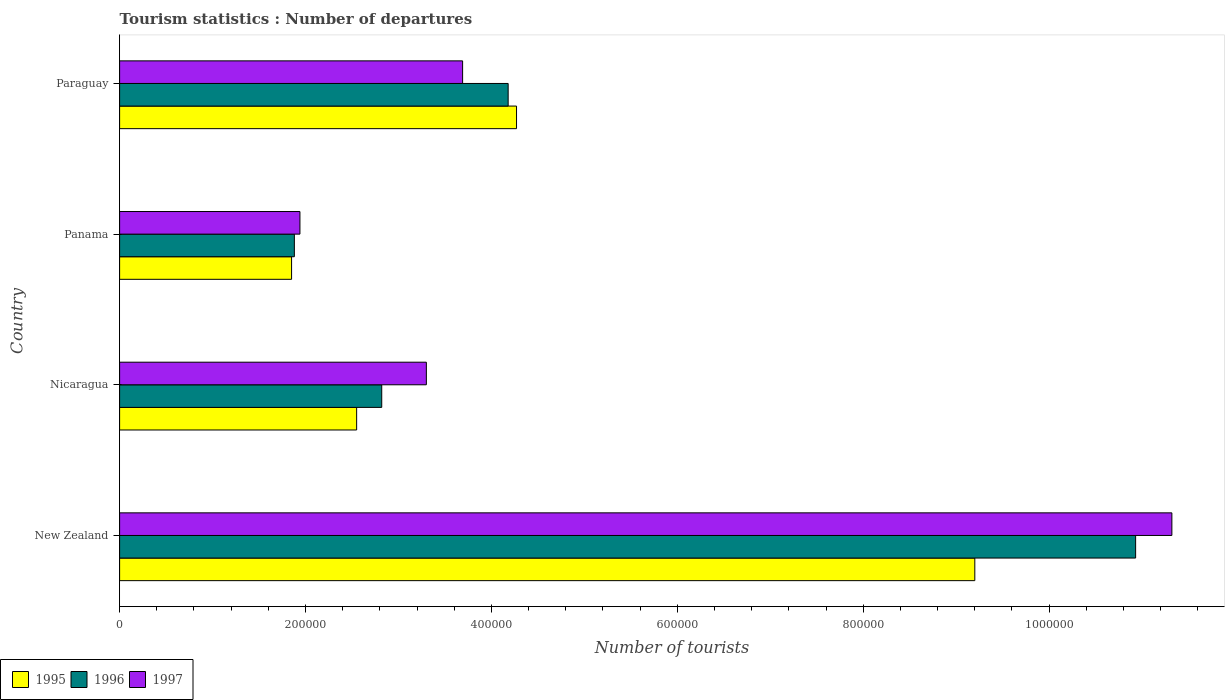How many groups of bars are there?
Ensure brevity in your answer.  4. How many bars are there on the 4th tick from the top?
Offer a terse response. 3. How many bars are there on the 2nd tick from the bottom?
Offer a very short reply. 3. What is the label of the 4th group of bars from the top?
Your answer should be compact. New Zealand. In how many cases, is the number of bars for a given country not equal to the number of legend labels?
Keep it short and to the point. 0. What is the number of tourist departures in 1995 in Paraguay?
Provide a succinct answer. 4.27e+05. Across all countries, what is the maximum number of tourist departures in 1995?
Give a very brief answer. 9.20e+05. Across all countries, what is the minimum number of tourist departures in 1996?
Keep it short and to the point. 1.88e+05. In which country was the number of tourist departures in 1997 maximum?
Keep it short and to the point. New Zealand. In which country was the number of tourist departures in 1996 minimum?
Your answer should be compact. Panama. What is the total number of tourist departures in 1997 in the graph?
Your answer should be compact. 2.02e+06. What is the difference between the number of tourist departures in 1997 in Nicaragua and that in Panama?
Provide a succinct answer. 1.36e+05. What is the difference between the number of tourist departures in 1995 in New Zealand and the number of tourist departures in 1997 in Paraguay?
Your answer should be very brief. 5.51e+05. What is the average number of tourist departures in 1997 per country?
Your response must be concise. 5.06e+05. What is the difference between the number of tourist departures in 1995 and number of tourist departures in 1996 in Paraguay?
Provide a short and direct response. 9000. What is the ratio of the number of tourist departures in 1996 in New Zealand to that in Panama?
Your response must be concise. 5.81. Is the difference between the number of tourist departures in 1995 in New Zealand and Nicaragua greater than the difference between the number of tourist departures in 1996 in New Zealand and Nicaragua?
Provide a short and direct response. No. What is the difference between the highest and the second highest number of tourist departures in 1996?
Provide a short and direct response. 6.75e+05. What is the difference between the highest and the lowest number of tourist departures in 1996?
Your response must be concise. 9.05e+05. Is the sum of the number of tourist departures in 1997 in New Zealand and Nicaragua greater than the maximum number of tourist departures in 1995 across all countries?
Make the answer very short. Yes. What does the 3rd bar from the top in Panama represents?
Provide a short and direct response. 1995. What does the 1st bar from the bottom in Paraguay represents?
Give a very brief answer. 1995. How many bars are there?
Your answer should be compact. 12. Are all the bars in the graph horizontal?
Give a very brief answer. Yes. Are the values on the major ticks of X-axis written in scientific E-notation?
Offer a very short reply. No. Does the graph contain grids?
Your answer should be compact. No. Where does the legend appear in the graph?
Ensure brevity in your answer.  Bottom left. How are the legend labels stacked?
Give a very brief answer. Horizontal. What is the title of the graph?
Provide a succinct answer. Tourism statistics : Number of departures. What is the label or title of the X-axis?
Your answer should be very brief. Number of tourists. What is the label or title of the Y-axis?
Your answer should be very brief. Country. What is the Number of tourists of 1995 in New Zealand?
Give a very brief answer. 9.20e+05. What is the Number of tourists of 1996 in New Zealand?
Give a very brief answer. 1.09e+06. What is the Number of tourists of 1997 in New Zealand?
Your answer should be very brief. 1.13e+06. What is the Number of tourists in 1995 in Nicaragua?
Your response must be concise. 2.55e+05. What is the Number of tourists of 1996 in Nicaragua?
Ensure brevity in your answer.  2.82e+05. What is the Number of tourists of 1995 in Panama?
Provide a succinct answer. 1.85e+05. What is the Number of tourists of 1996 in Panama?
Provide a succinct answer. 1.88e+05. What is the Number of tourists in 1997 in Panama?
Ensure brevity in your answer.  1.94e+05. What is the Number of tourists in 1995 in Paraguay?
Your answer should be compact. 4.27e+05. What is the Number of tourists in 1996 in Paraguay?
Ensure brevity in your answer.  4.18e+05. What is the Number of tourists in 1997 in Paraguay?
Your answer should be very brief. 3.69e+05. Across all countries, what is the maximum Number of tourists of 1995?
Provide a succinct answer. 9.20e+05. Across all countries, what is the maximum Number of tourists in 1996?
Offer a terse response. 1.09e+06. Across all countries, what is the maximum Number of tourists in 1997?
Make the answer very short. 1.13e+06. Across all countries, what is the minimum Number of tourists in 1995?
Ensure brevity in your answer.  1.85e+05. Across all countries, what is the minimum Number of tourists in 1996?
Provide a succinct answer. 1.88e+05. Across all countries, what is the minimum Number of tourists in 1997?
Provide a succinct answer. 1.94e+05. What is the total Number of tourists of 1995 in the graph?
Your answer should be very brief. 1.79e+06. What is the total Number of tourists of 1996 in the graph?
Provide a short and direct response. 1.98e+06. What is the total Number of tourists in 1997 in the graph?
Provide a short and direct response. 2.02e+06. What is the difference between the Number of tourists of 1995 in New Zealand and that in Nicaragua?
Provide a short and direct response. 6.65e+05. What is the difference between the Number of tourists in 1996 in New Zealand and that in Nicaragua?
Make the answer very short. 8.11e+05. What is the difference between the Number of tourists in 1997 in New Zealand and that in Nicaragua?
Your answer should be compact. 8.02e+05. What is the difference between the Number of tourists in 1995 in New Zealand and that in Panama?
Ensure brevity in your answer.  7.35e+05. What is the difference between the Number of tourists in 1996 in New Zealand and that in Panama?
Provide a short and direct response. 9.05e+05. What is the difference between the Number of tourists in 1997 in New Zealand and that in Panama?
Keep it short and to the point. 9.38e+05. What is the difference between the Number of tourists of 1995 in New Zealand and that in Paraguay?
Provide a short and direct response. 4.93e+05. What is the difference between the Number of tourists in 1996 in New Zealand and that in Paraguay?
Offer a terse response. 6.75e+05. What is the difference between the Number of tourists of 1997 in New Zealand and that in Paraguay?
Your answer should be very brief. 7.63e+05. What is the difference between the Number of tourists in 1996 in Nicaragua and that in Panama?
Your answer should be very brief. 9.40e+04. What is the difference between the Number of tourists in 1997 in Nicaragua and that in Panama?
Give a very brief answer. 1.36e+05. What is the difference between the Number of tourists in 1995 in Nicaragua and that in Paraguay?
Provide a succinct answer. -1.72e+05. What is the difference between the Number of tourists of 1996 in Nicaragua and that in Paraguay?
Keep it short and to the point. -1.36e+05. What is the difference between the Number of tourists in 1997 in Nicaragua and that in Paraguay?
Provide a succinct answer. -3.90e+04. What is the difference between the Number of tourists of 1995 in Panama and that in Paraguay?
Keep it short and to the point. -2.42e+05. What is the difference between the Number of tourists of 1996 in Panama and that in Paraguay?
Keep it short and to the point. -2.30e+05. What is the difference between the Number of tourists of 1997 in Panama and that in Paraguay?
Ensure brevity in your answer.  -1.75e+05. What is the difference between the Number of tourists in 1995 in New Zealand and the Number of tourists in 1996 in Nicaragua?
Provide a short and direct response. 6.38e+05. What is the difference between the Number of tourists of 1995 in New Zealand and the Number of tourists of 1997 in Nicaragua?
Give a very brief answer. 5.90e+05. What is the difference between the Number of tourists of 1996 in New Zealand and the Number of tourists of 1997 in Nicaragua?
Give a very brief answer. 7.63e+05. What is the difference between the Number of tourists of 1995 in New Zealand and the Number of tourists of 1996 in Panama?
Keep it short and to the point. 7.32e+05. What is the difference between the Number of tourists of 1995 in New Zealand and the Number of tourists of 1997 in Panama?
Make the answer very short. 7.26e+05. What is the difference between the Number of tourists in 1996 in New Zealand and the Number of tourists in 1997 in Panama?
Provide a short and direct response. 8.99e+05. What is the difference between the Number of tourists of 1995 in New Zealand and the Number of tourists of 1996 in Paraguay?
Ensure brevity in your answer.  5.02e+05. What is the difference between the Number of tourists of 1995 in New Zealand and the Number of tourists of 1997 in Paraguay?
Make the answer very short. 5.51e+05. What is the difference between the Number of tourists in 1996 in New Zealand and the Number of tourists in 1997 in Paraguay?
Make the answer very short. 7.24e+05. What is the difference between the Number of tourists in 1995 in Nicaragua and the Number of tourists in 1996 in Panama?
Ensure brevity in your answer.  6.70e+04. What is the difference between the Number of tourists of 1995 in Nicaragua and the Number of tourists of 1997 in Panama?
Ensure brevity in your answer.  6.10e+04. What is the difference between the Number of tourists of 1996 in Nicaragua and the Number of tourists of 1997 in Panama?
Ensure brevity in your answer.  8.80e+04. What is the difference between the Number of tourists of 1995 in Nicaragua and the Number of tourists of 1996 in Paraguay?
Provide a succinct answer. -1.63e+05. What is the difference between the Number of tourists in 1995 in Nicaragua and the Number of tourists in 1997 in Paraguay?
Offer a very short reply. -1.14e+05. What is the difference between the Number of tourists in 1996 in Nicaragua and the Number of tourists in 1997 in Paraguay?
Ensure brevity in your answer.  -8.70e+04. What is the difference between the Number of tourists of 1995 in Panama and the Number of tourists of 1996 in Paraguay?
Provide a succinct answer. -2.33e+05. What is the difference between the Number of tourists in 1995 in Panama and the Number of tourists in 1997 in Paraguay?
Your answer should be compact. -1.84e+05. What is the difference between the Number of tourists of 1996 in Panama and the Number of tourists of 1997 in Paraguay?
Provide a short and direct response. -1.81e+05. What is the average Number of tourists of 1995 per country?
Your response must be concise. 4.47e+05. What is the average Number of tourists in 1996 per country?
Ensure brevity in your answer.  4.95e+05. What is the average Number of tourists of 1997 per country?
Ensure brevity in your answer.  5.06e+05. What is the difference between the Number of tourists in 1995 and Number of tourists in 1996 in New Zealand?
Keep it short and to the point. -1.73e+05. What is the difference between the Number of tourists of 1995 and Number of tourists of 1997 in New Zealand?
Provide a short and direct response. -2.12e+05. What is the difference between the Number of tourists in 1996 and Number of tourists in 1997 in New Zealand?
Keep it short and to the point. -3.90e+04. What is the difference between the Number of tourists in 1995 and Number of tourists in 1996 in Nicaragua?
Ensure brevity in your answer.  -2.70e+04. What is the difference between the Number of tourists of 1995 and Number of tourists of 1997 in Nicaragua?
Your response must be concise. -7.50e+04. What is the difference between the Number of tourists in 1996 and Number of tourists in 1997 in Nicaragua?
Keep it short and to the point. -4.80e+04. What is the difference between the Number of tourists of 1995 and Number of tourists of 1996 in Panama?
Your answer should be compact. -3000. What is the difference between the Number of tourists of 1995 and Number of tourists of 1997 in Panama?
Your response must be concise. -9000. What is the difference between the Number of tourists in 1996 and Number of tourists in 1997 in Panama?
Offer a very short reply. -6000. What is the difference between the Number of tourists in 1995 and Number of tourists in 1996 in Paraguay?
Make the answer very short. 9000. What is the difference between the Number of tourists of 1995 and Number of tourists of 1997 in Paraguay?
Give a very brief answer. 5.80e+04. What is the difference between the Number of tourists in 1996 and Number of tourists in 1997 in Paraguay?
Your answer should be very brief. 4.90e+04. What is the ratio of the Number of tourists of 1995 in New Zealand to that in Nicaragua?
Offer a very short reply. 3.61. What is the ratio of the Number of tourists in 1996 in New Zealand to that in Nicaragua?
Offer a very short reply. 3.88. What is the ratio of the Number of tourists of 1997 in New Zealand to that in Nicaragua?
Your answer should be very brief. 3.43. What is the ratio of the Number of tourists of 1995 in New Zealand to that in Panama?
Offer a terse response. 4.97. What is the ratio of the Number of tourists of 1996 in New Zealand to that in Panama?
Provide a succinct answer. 5.81. What is the ratio of the Number of tourists in 1997 in New Zealand to that in Panama?
Offer a terse response. 5.84. What is the ratio of the Number of tourists of 1995 in New Zealand to that in Paraguay?
Provide a succinct answer. 2.15. What is the ratio of the Number of tourists of 1996 in New Zealand to that in Paraguay?
Offer a terse response. 2.61. What is the ratio of the Number of tourists of 1997 in New Zealand to that in Paraguay?
Provide a succinct answer. 3.07. What is the ratio of the Number of tourists of 1995 in Nicaragua to that in Panama?
Provide a succinct answer. 1.38. What is the ratio of the Number of tourists of 1997 in Nicaragua to that in Panama?
Keep it short and to the point. 1.7. What is the ratio of the Number of tourists of 1995 in Nicaragua to that in Paraguay?
Give a very brief answer. 0.6. What is the ratio of the Number of tourists in 1996 in Nicaragua to that in Paraguay?
Give a very brief answer. 0.67. What is the ratio of the Number of tourists of 1997 in Nicaragua to that in Paraguay?
Give a very brief answer. 0.89. What is the ratio of the Number of tourists of 1995 in Panama to that in Paraguay?
Your response must be concise. 0.43. What is the ratio of the Number of tourists of 1996 in Panama to that in Paraguay?
Ensure brevity in your answer.  0.45. What is the ratio of the Number of tourists in 1997 in Panama to that in Paraguay?
Your response must be concise. 0.53. What is the difference between the highest and the second highest Number of tourists of 1995?
Provide a short and direct response. 4.93e+05. What is the difference between the highest and the second highest Number of tourists of 1996?
Your answer should be very brief. 6.75e+05. What is the difference between the highest and the second highest Number of tourists in 1997?
Offer a terse response. 7.63e+05. What is the difference between the highest and the lowest Number of tourists of 1995?
Offer a very short reply. 7.35e+05. What is the difference between the highest and the lowest Number of tourists of 1996?
Offer a very short reply. 9.05e+05. What is the difference between the highest and the lowest Number of tourists in 1997?
Make the answer very short. 9.38e+05. 